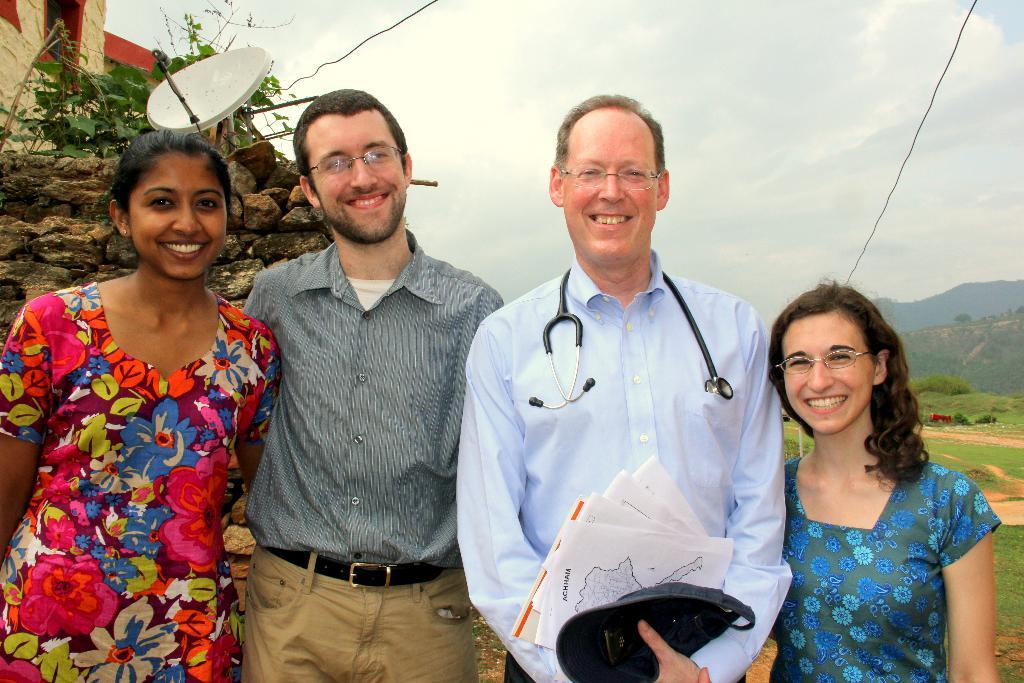How many people are in the image? There are four persons standing in the middle of the image. What are the expressions on the faces of the persons? The persons are smiling. What can be seen behind the persons? There are trees behind the persons, followed by a wall. What is visible in the distance behind the wall? There are hills visible in the background. What else can be seen in the background? Wires are present in the background. What is the condition of the sky in the image? There are clouds in the sky at the top of the image. What type of clock is hanging from the tree in the image? There is no clock present in the image; it only features four persons, trees, a wall, hills, wires, and clouds. 